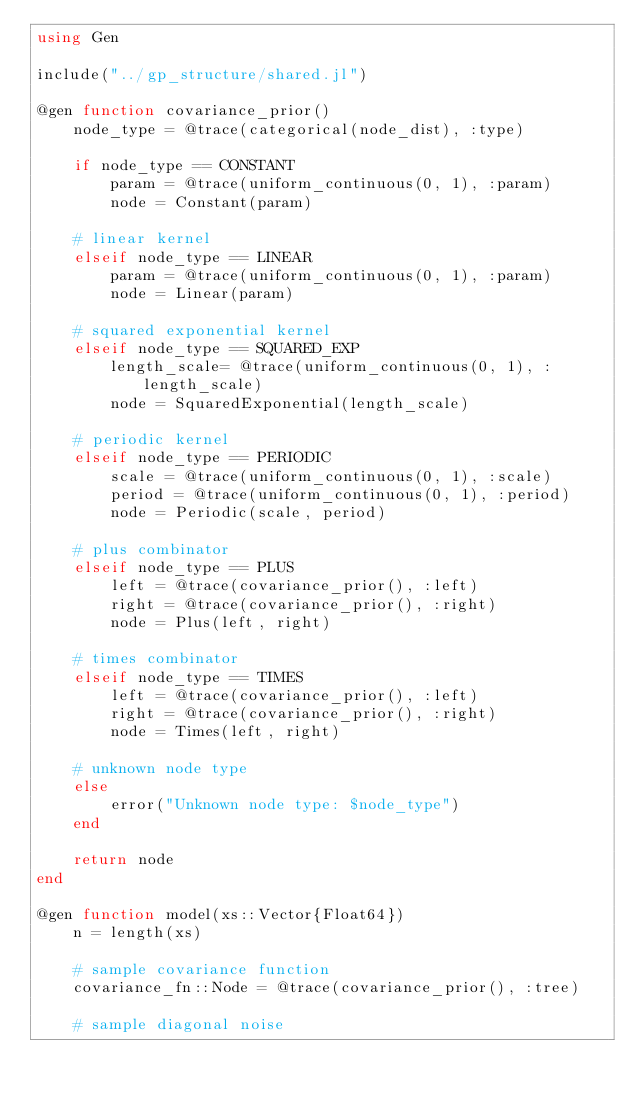<code> <loc_0><loc_0><loc_500><loc_500><_Julia_>using Gen

include("../gp_structure/shared.jl")

@gen function covariance_prior()
    node_type = @trace(categorical(node_dist), :type)

    if node_type == CONSTANT
        param = @trace(uniform_continuous(0, 1), :param)
        node = Constant(param)

    # linear kernel
    elseif node_type == LINEAR
        param = @trace(uniform_continuous(0, 1), :param)
        node = Linear(param)

    # squared exponential kernel
    elseif node_type == SQUARED_EXP
        length_scale= @trace(uniform_continuous(0, 1), :length_scale)
        node = SquaredExponential(length_scale)

    # periodic kernel
    elseif node_type == PERIODIC
        scale = @trace(uniform_continuous(0, 1), :scale)
        period = @trace(uniform_continuous(0, 1), :period)
        node = Periodic(scale, period)

    # plus combinator
    elseif node_type == PLUS
        left = @trace(covariance_prior(), :left)
        right = @trace(covariance_prior(), :right)
        node = Plus(left, right)

    # times combinator
    elseif node_type == TIMES
        left = @trace(covariance_prior(), :left)
        right = @trace(covariance_prior(), :right)
        node = Times(left, right)

    # unknown node type
    else
        error("Unknown node type: $node_type")
    end

    return node
end

@gen function model(xs::Vector{Float64})
    n = length(xs)

    # sample covariance function
    covariance_fn::Node = @trace(covariance_prior(), :tree)

    # sample diagonal noise</code> 